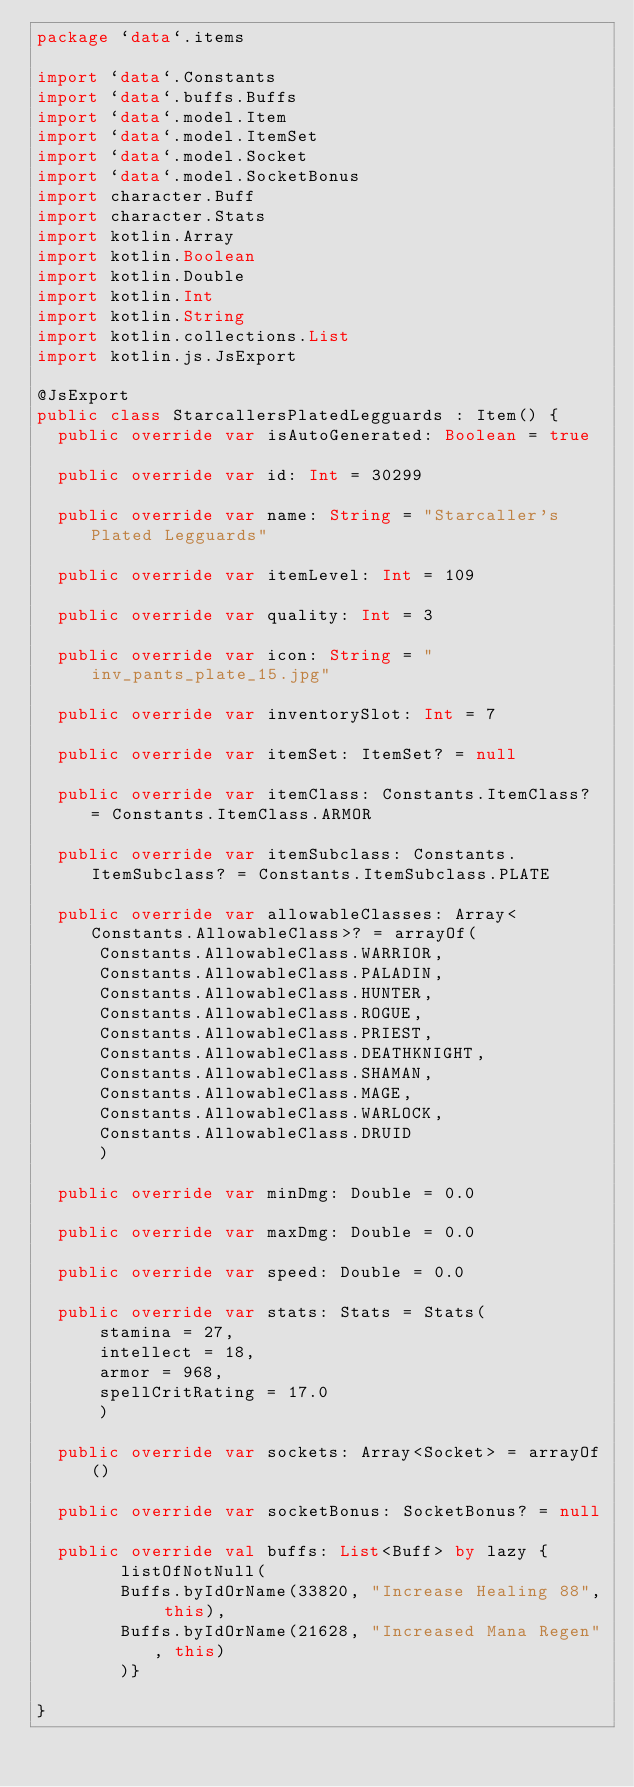<code> <loc_0><loc_0><loc_500><loc_500><_Kotlin_>package `data`.items

import `data`.Constants
import `data`.buffs.Buffs
import `data`.model.Item
import `data`.model.ItemSet
import `data`.model.Socket
import `data`.model.SocketBonus
import character.Buff
import character.Stats
import kotlin.Array
import kotlin.Boolean
import kotlin.Double
import kotlin.Int
import kotlin.String
import kotlin.collections.List
import kotlin.js.JsExport

@JsExport
public class StarcallersPlatedLegguards : Item() {
  public override var isAutoGenerated: Boolean = true

  public override var id: Int = 30299

  public override var name: String = "Starcaller's Plated Legguards"

  public override var itemLevel: Int = 109

  public override var quality: Int = 3

  public override var icon: String = "inv_pants_plate_15.jpg"

  public override var inventorySlot: Int = 7

  public override var itemSet: ItemSet? = null

  public override var itemClass: Constants.ItemClass? = Constants.ItemClass.ARMOR

  public override var itemSubclass: Constants.ItemSubclass? = Constants.ItemSubclass.PLATE

  public override var allowableClasses: Array<Constants.AllowableClass>? = arrayOf(
      Constants.AllowableClass.WARRIOR,
      Constants.AllowableClass.PALADIN,
      Constants.AllowableClass.HUNTER,
      Constants.AllowableClass.ROGUE,
      Constants.AllowableClass.PRIEST,
      Constants.AllowableClass.DEATHKNIGHT,
      Constants.AllowableClass.SHAMAN,
      Constants.AllowableClass.MAGE,
      Constants.AllowableClass.WARLOCK,
      Constants.AllowableClass.DRUID
      )

  public override var minDmg: Double = 0.0

  public override var maxDmg: Double = 0.0

  public override var speed: Double = 0.0

  public override var stats: Stats = Stats(
      stamina = 27,
      intellect = 18,
      armor = 968,
      spellCritRating = 17.0
      )

  public override var sockets: Array<Socket> = arrayOf()

  public override var socketBonus: SocketBonus? = null

  public override val buffs: List<Buff> by lazy {
        listOfNotNull(
        Buffs.byIdOrName(33820, "Increase Healing 88", this),
        Buffs.byIdOrName(21628, "Increased Mana Regen", this)
        )}

}
</code> 